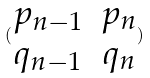Convert formula to latex. <formula><loc_0><loc_0><loc_500><loc_500>( \begin{matrix} p _ { n - 1 } & p _ { n } \\ q _ { n - 1 } & q _ { n } \end{matrix} )</formula> 